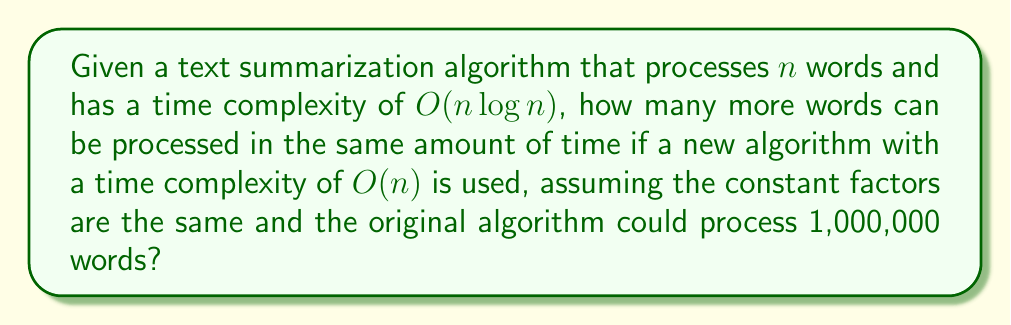Provide a solution to this math problem. To solve this problem, we need to follow these steps:

1) Let's denote the time taken by the original algorithm as $T$. We know that:

   $T = c \cdot 1,000,000 \log 1,000,000$

   where $c$ is some constant.

2) For the new algorithm, we want to find $x$ such that:

   $T = c \cdot x$

   where $x$ is the number of words the new algorithm can process in the same time.

3) Equating these:

   $c \cdot 1,000,000 \log 1,000,000 = c \cdot x$

4) The constant $c$ cancels out on both sides:

   $1,000,000 \log 1,000,000 = x$

5) Now we need to calculate $\log 1,000,000$:

   $\log 1,000,000 = \log 10^6 = 6 \log 10 \approx 6 \cdot 2.3026 = 13.8155$

6) Substituting this back:

   $1,000,000 \cdot 13.8155 = x$

7) Calculating:

   $x = 13,815,500$

8) To find how many more words can be processed, we subtract the original number:

   $13,815,500 - 1,000,000 = 12,815,500$

Therefore, the new algorithm can process approximately 12,815,500 more words in the same amount of time.
Answer: Approximately 12,815,500 more words 